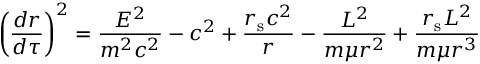<formula> <loc_0><loc_0><loc_500><loc_500>\left ( { \frac { d r } { d \tau } } \right ) ^ { 2 } = { \frac { E ^ { 2 } } { m ^ { 2 } c ^ { 2 } } } - c ^ { 2 } + { \frac { r _ { s } c ^ { 2 } } { r } } - { \frac { L ^ { 2 } } { m \mu r ^ { 2 } } } + { \frac { r _ { s } L ^ { 2 } } { m \mu r ^ { 3 } } }</formula> 